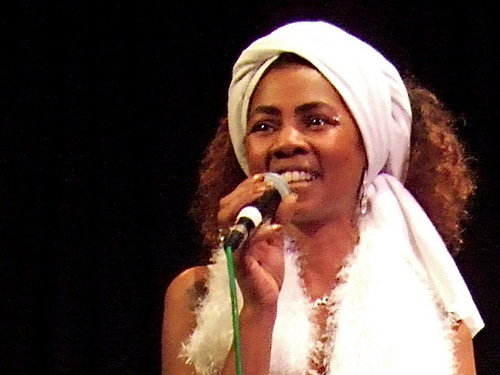<image>
Is there a mic in the head? No. The mic is not contained within the head. These objects have a different spatial relationship. Where is the singer in relation to the mike? Is it in front of the mike? No. The singer is not in front of the mike. The spatial positioning shows a different relationship between these objects. 